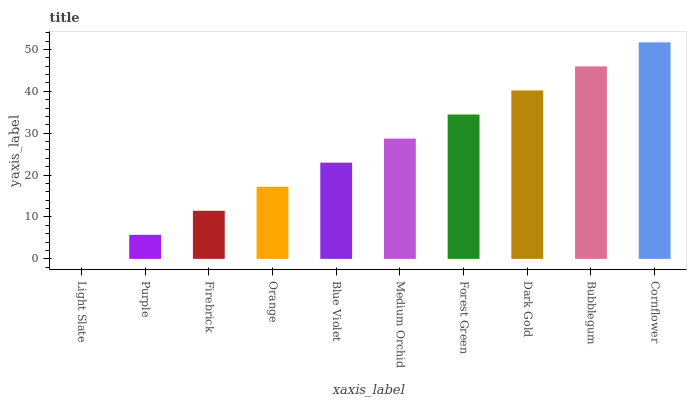Is Cornflower the maximum?
Answer yes or no. Yes. Is Purple the minimum?
Answer yes or no. No. Is Purple the maximum?
Answer yes or no. No. Is Purple greater than Light Slate?
Answer yes or no. Yes. Is Light Slate less than Purple?
Answer yes or no. Yes. Is Light Slate greater than Purple?
Answer yes or no. No. Is Purple less than Light Slate?
Answer yes or no. No. Is Medium Orchid the high median?
Answer yes or no. Yes. Is Blue Violet the low median?
Answer yes or no. Yes. Is Firebrick the high median?
Answer yes or no. No. Is Medium Orchid the low median?
Answer yes or no. No. 